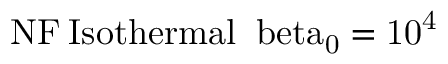<formula> <loc_0><loc_0><loc_500><loc_500>{ N F } \, \mathrm { { I s o t h e r m a l } \, \ b e t a _ { 0 } = 1 0 ^ { 4 } }</formula> 